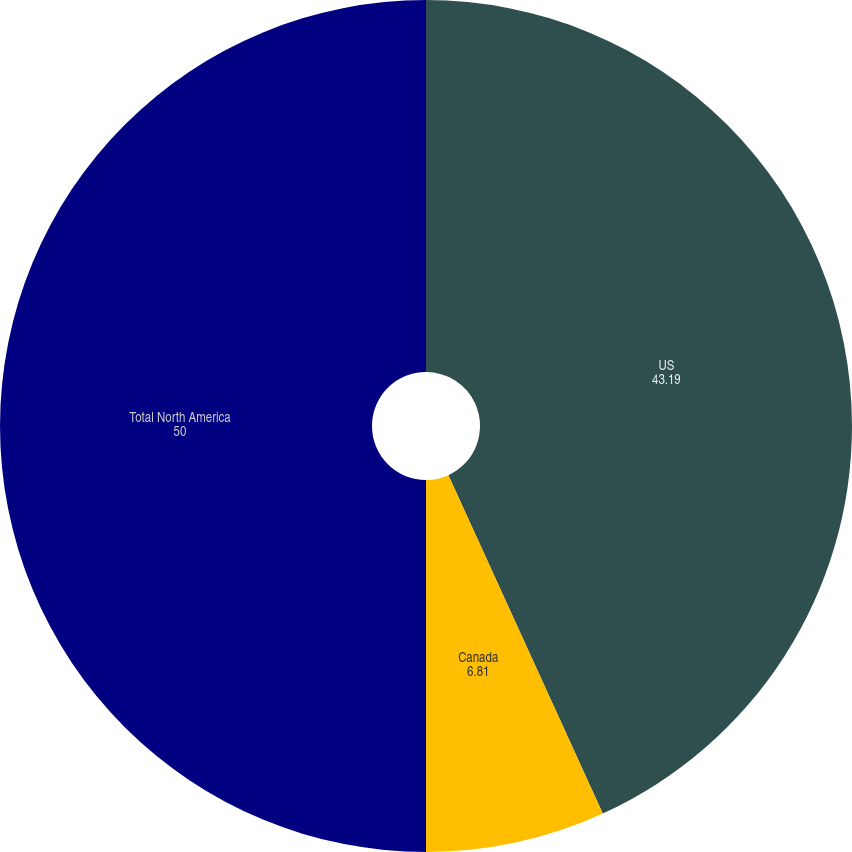Convert chart to OTSL. <chart><loc_0><loc_0><loc_500><loc_500><pie_chart><fcel>US<fcel>Canada<fcel>Total North America<nl><fcel>43.19%<fcel>6.81%<fcel>50.0%<nl></chart> 